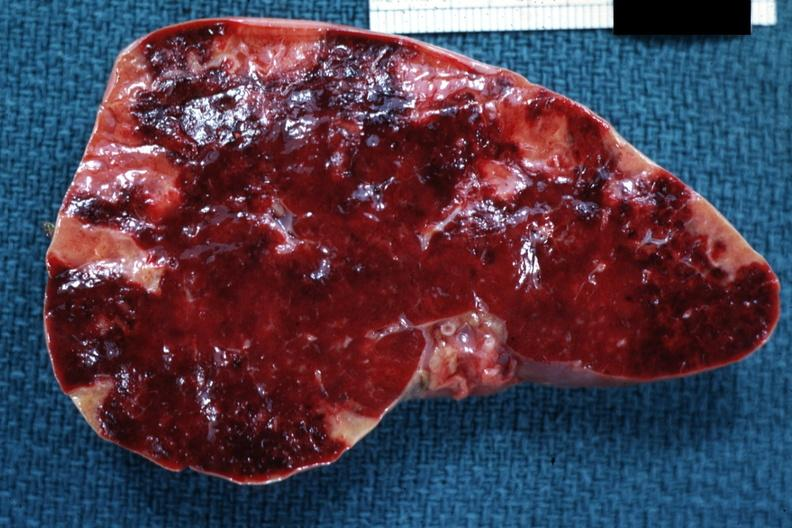where is this part in?
Answer the question using a single word or phrase. Spleen 